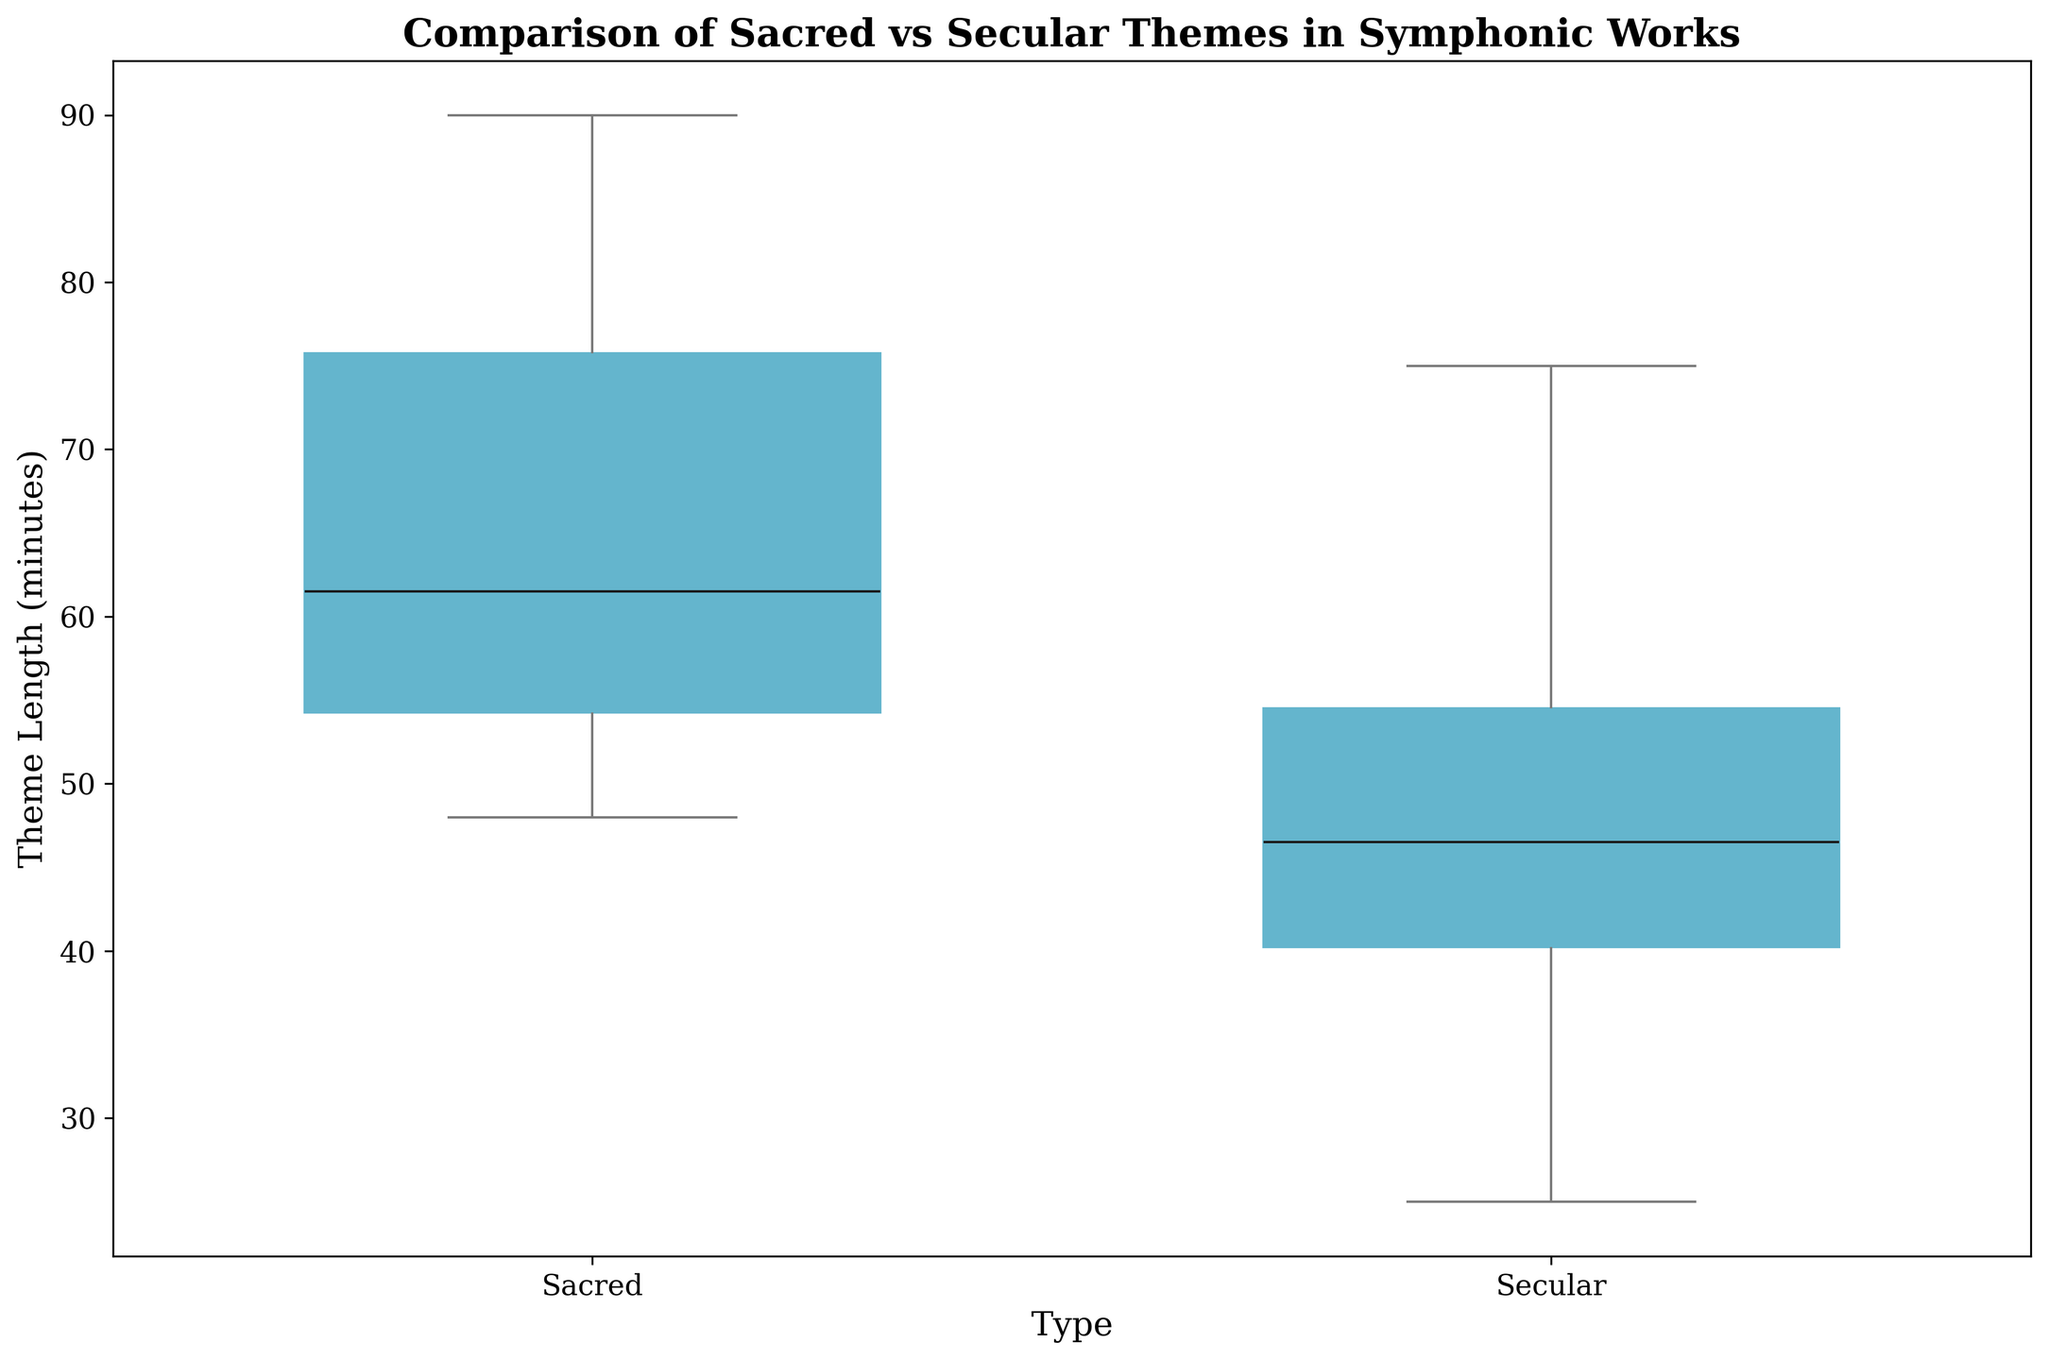What is the median theme length for sacred works? The median is the middle value of the sorted list of theme lengths for sacred works. Look at the line inside the boxes for sacred type, and find the middle value.
Answer: 63 How does the median theme length of sacred works compare to that of secular works? The median is the line inside the boxes. Compare the position of the medians for sacred and secular works. The median for sacred works is higher than that for secular works.
Answer: Sacred is higher Which type has a greater range of theme lengths? The range is the difference between the maximum and minimum values. Compare the lengths of the whiskers (lines extending from the boxes) and the boxes themselves for both types.
Answer: Secular Do sacred works have any outliers? Outliers are often shown as points outside the whiskers. Look for any distinct points outside the whiskers for sacred works.
Answer: No What is the interquartile range (IQR) for secular works? The IQR is the range within the box, from Q1 (25th percentile) to Q3 (75th percentile). Measure the height of the box for secular works.
Answer: 25 (since 75th percentile is about 50 and the 25th percentile is about 25) Which type shows a higher maximum theme length? The maximum value is indicated by the top whisker or the highest point if there are outliers. Compare these for both sacred and secular works.
Answer: Sacred Are there more composers with sacred theme lengths over 70 minutes or secular theme lengths over 60 minutes? Identify the number of points above 70 for sacred and above 60 for secular by looking at where the data points lie.
Answer: Sacred over 70 minutes What is the lower quartile (Q1) for secular works? The lower quartile is the bottom edge of the box for secular works. Determine its value from the plot.
Answer: 35 What is the spread of theme lengths for sacred works compared to secular works? The spread is depicted by the total length of the box and whiskers. Compare the overall height from whisker to whisker for both types.
Answer: Sacred works have a wider spread Is there a composer whose secular work theme length is atypically high? Look for outliers (points outside the whiskers) on the secular side to see if any points are significantly higher than the rest.
Answer: No 